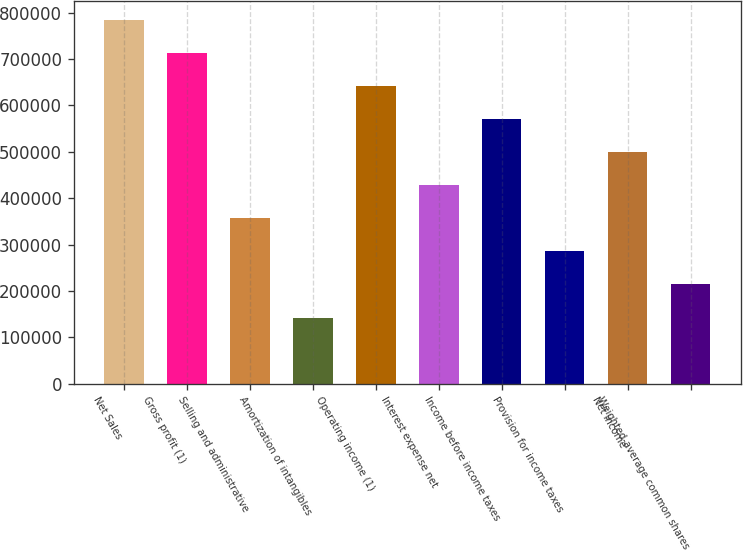Convert chart. <chart><loc_0><loc_0><loc_500><loc_500><bar_chart><fcel>Net Sales<fcel>Gross profit (1)<fcel>Selling and administrative<fcel>Amortization of intangibles<fcel>Operating income (1)<fcel>Interest expense net<fcel>Income before income taxes<fcel>Provision for income taxes<fcel>Net income<fcel>Weighted-average common shares<nl><fcel>785082<fcel>713711<fcel>356857<fcel>142744<fcel>642340<fcel>428228<fcel>570969<fcel>285486<fcel>499599<fcel>214115<nl></chart> 